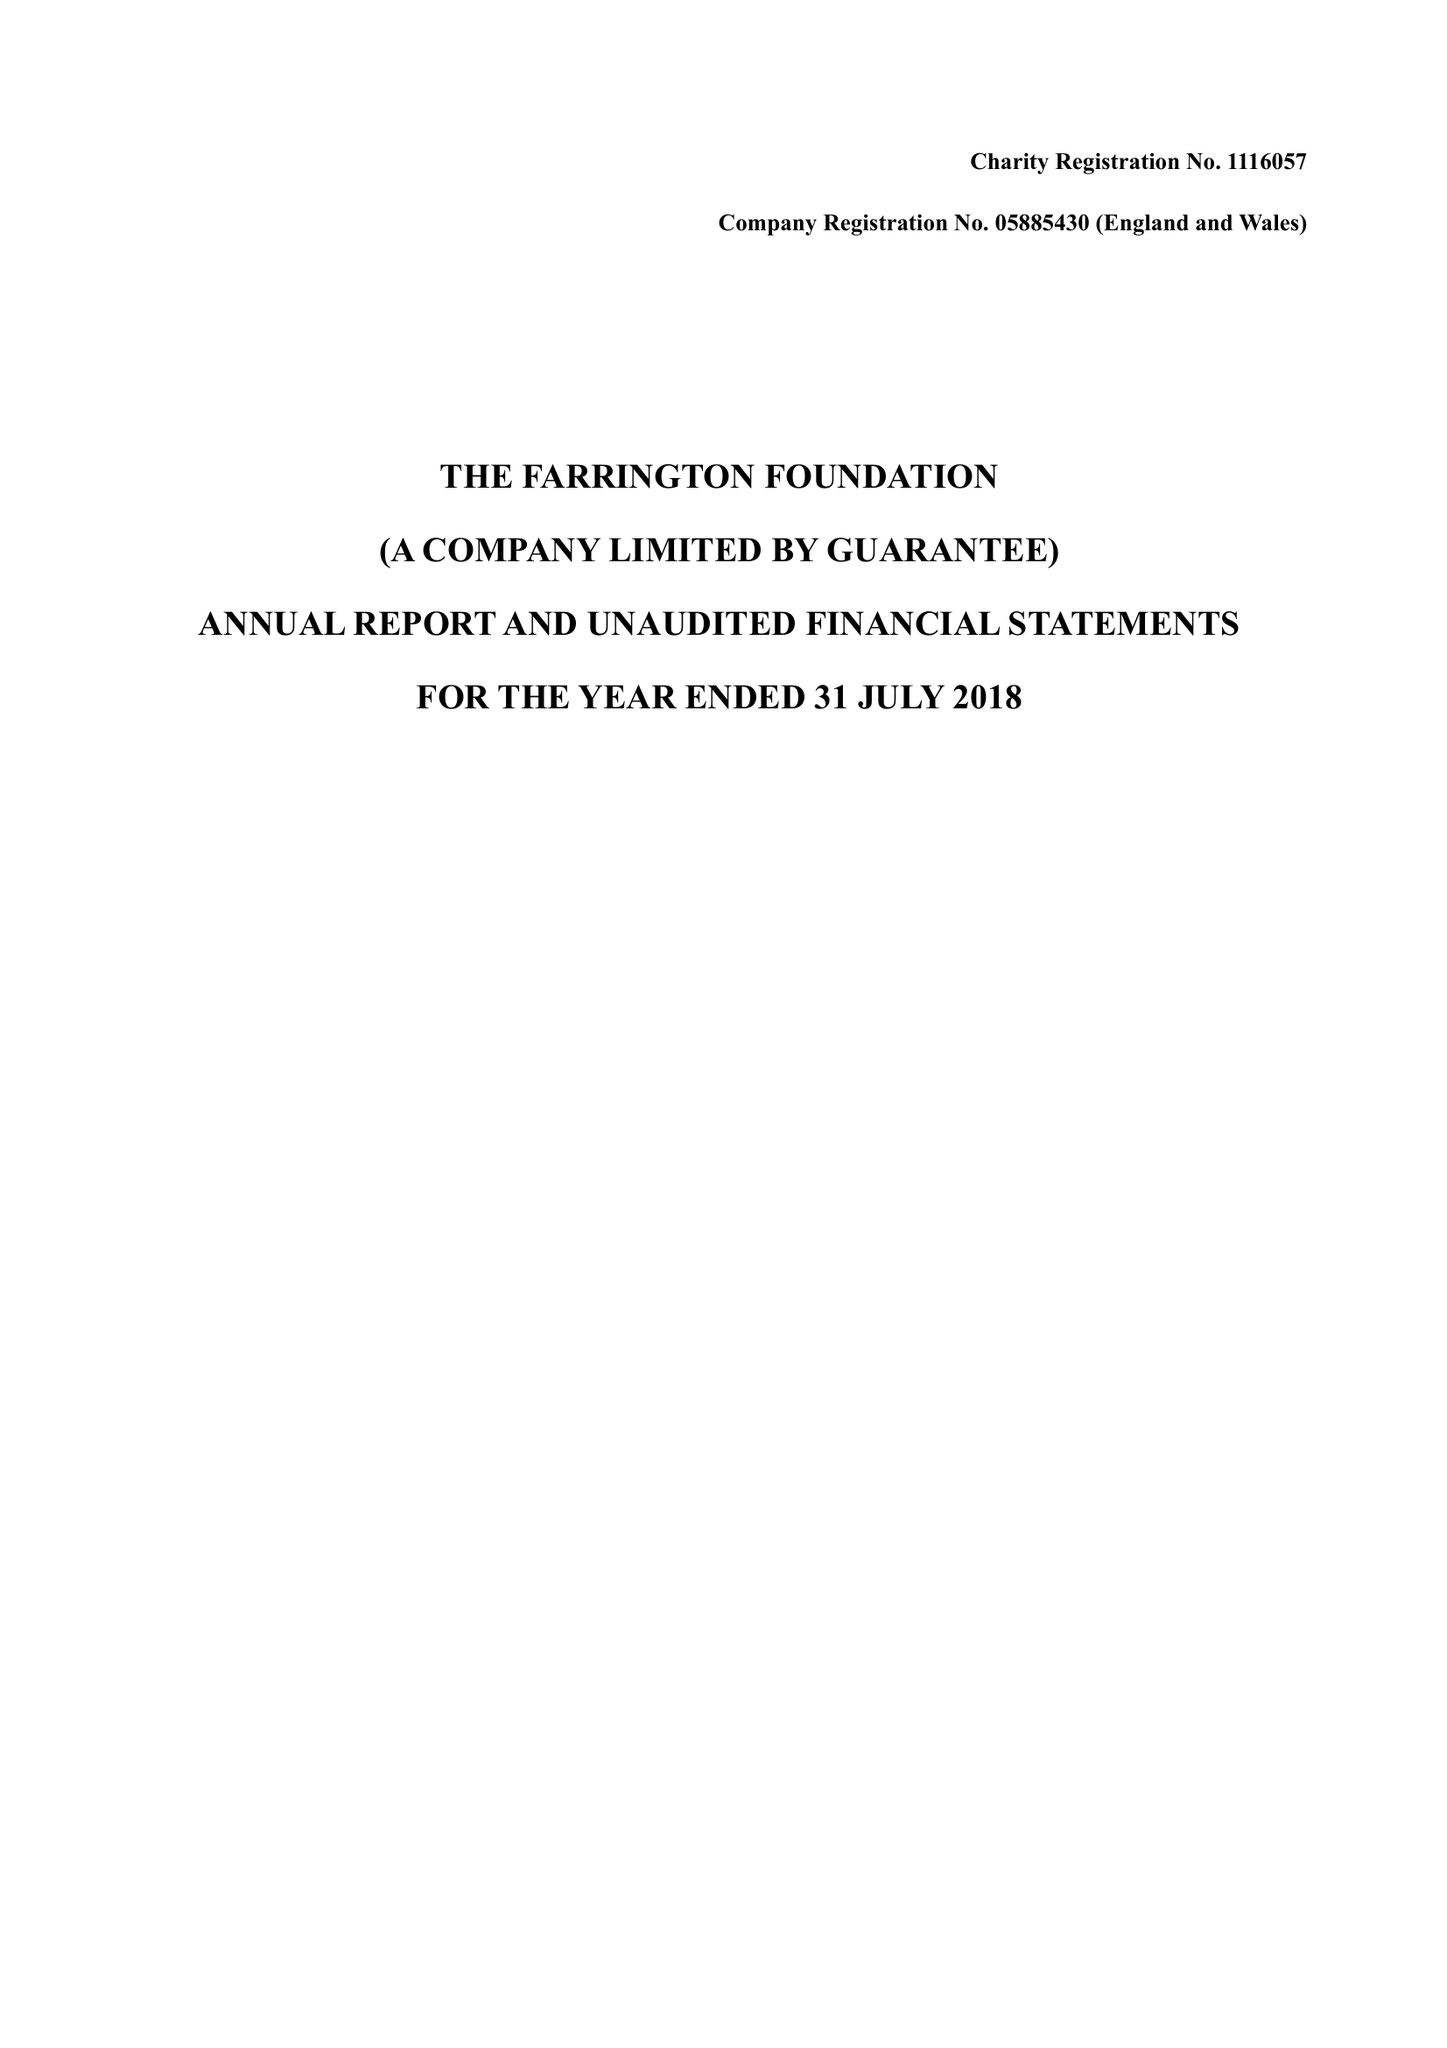What is the value for the address__postcode?
Answer the question using a single word or phrase. HA6 3SW 